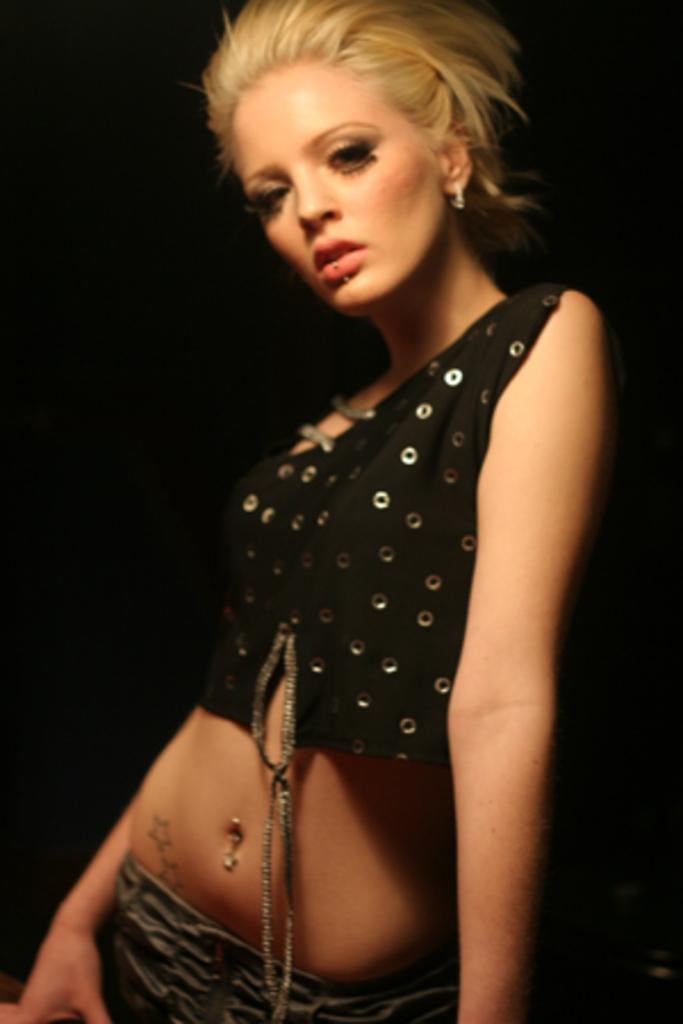What is the main subject of the image? There is a lady standing in the image. Can you describe the background of the image? The background of the image is dark. How much salt is on the table next to the lady in the image? There is no table or salt present in the image; it only features a lady standing with a dark background. 